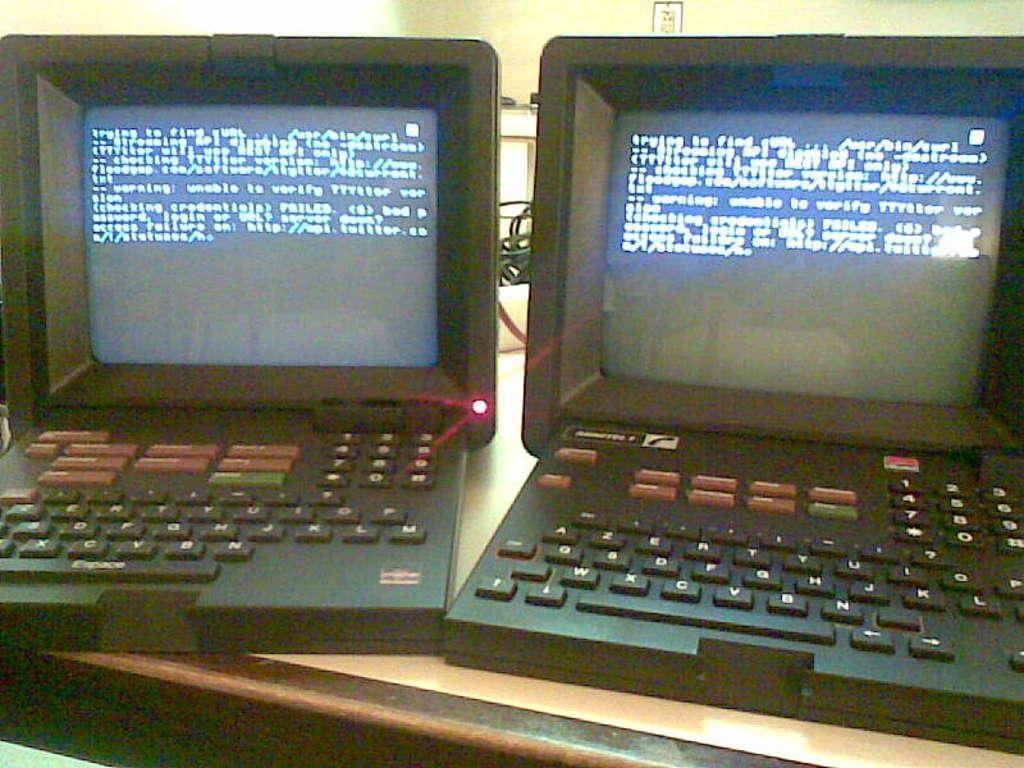How would you summarize this image in a sentence or two? This picture is clicked inside. In the foreground we can see the two electronic devices are placed on the top of the table. In the background we can see the picture frame hanging on the wall and we can see the cables and some other objects and we can see the text on the display of the electronic devices. 